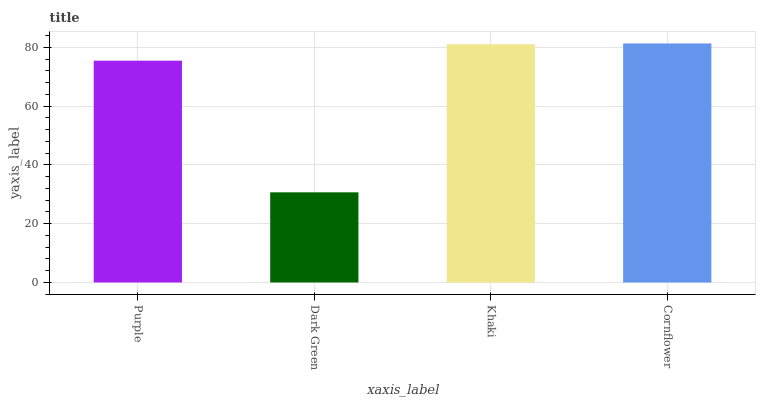Is Dark Green the minimum?
Answer yes or no. Yes. Is Cornflower the maximum?
Answer yes or no. Yes. Is Khaki the minimum?
Answer yes or no. No. Is Khaki the maximum?
Answer yes or no. No. Is Khaki greater than Dark Green?
Answer yes or no. Yes. Is Dark Green less than Khaki?
Answer yes or no. Yes. Is Dark Green greater than Khaki?
Answer yes or no. No. Is Khaki less than Dark Green?
Answer yes or no. No. Is Khaki the high median?
Answer yes or no. Yes. Is Purple the low median?
Answer yes or no. Yes. Is Purple the high median?
Answer yes or no. No. Is Dark Green the low median?
Answer yes or no. No. 